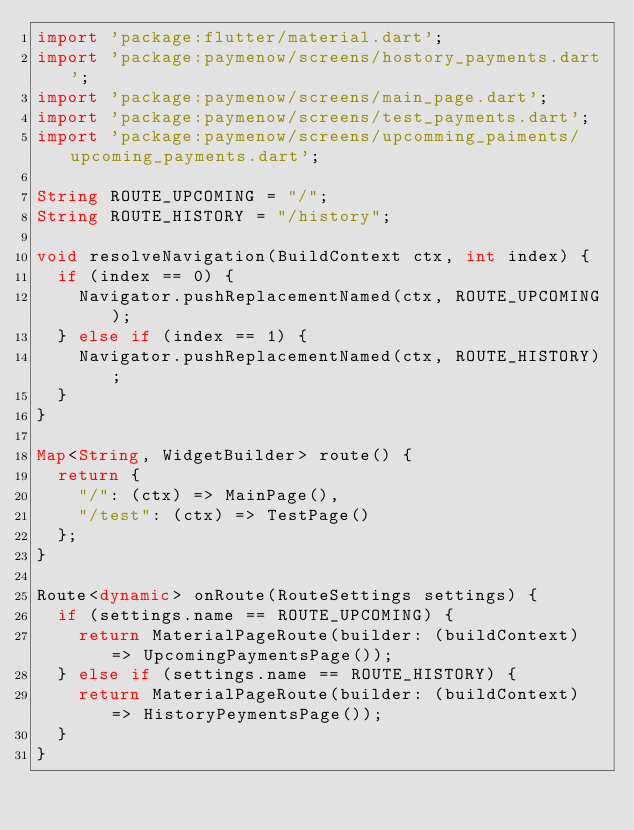Convert code to text. <code><loc_0><loc_0><loc_500><loc_500><_Dart_>import 'package:flutter/material.dart';
import 'package:paymenow/screens/hostory_payments.dart';
import 'package:paymenow/screens/main_page.dart';
import 'package:paymenow/screens/test_payments.dart';
import 'package:paymenow/screens/upcomming_paiments/upcoming_payments.dart';

String ROUTE_UPCOMING = "/";
String ROUTE_HISTORY = "/history";

void resolveNavigation(BuildContext ctx, int index) {
  if (index == 0) {
    Navigator.pushReplacementNamed(ctx, ROUTE_UPCOMING);
  } else if (index == 1) {
    Navigator.pushReplacementNamed(ctx, ROUTE_HISTORY);
  }
}

Map<String, WidgetBuilder> route() {
  return {
    "/": (ctx) => MainPage(),
    "/test": (ctx) => TestPage()
  };
}

Route<dynamic> onRoute(RouteSettings settings) {
  if (settings.name == ROUTE_UPCOMING) {
    return MaterialPageRoute(builder: (buildContext) => UpcomingPaymentsPage());
  } else if (settings.name == ROUTE_HISTORY) {
    return MaterialPageRoute(builder: (buildContext) => HistoryPeymentsPage());
  }
}
</code> 